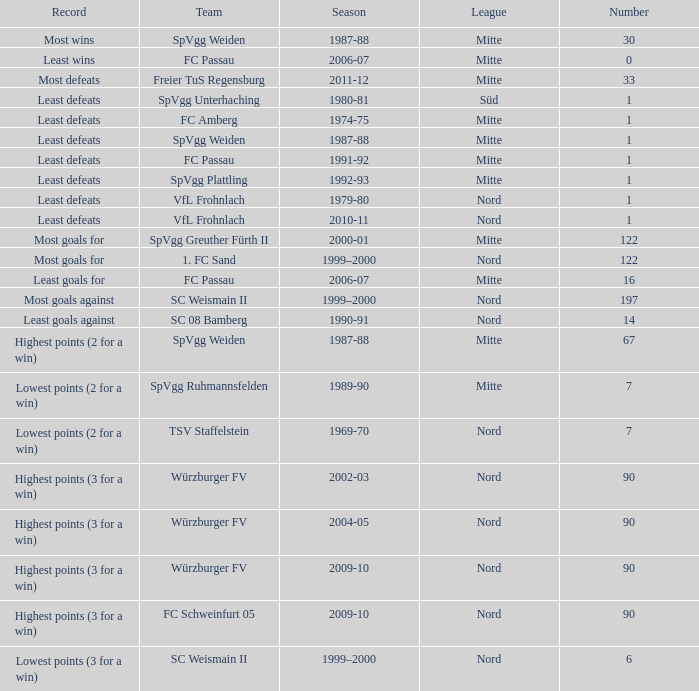Which association has a figure below 122, and the lowest victories as the record? Mitte. 